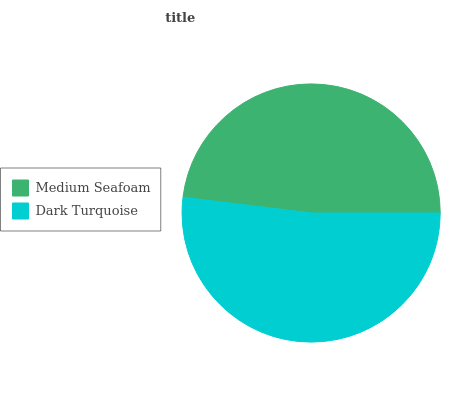Is Medium Seafoam the minimum?
Answer yes or no. Yes. Is Dark Turquoise the maximum?
Answer yes or no. Yes. Is Dark Turquoise the minimum?
Answer yes or no. No. Is Dark Turquoise greater than Medium Seafoam?
Answer yes or no. Yes. Is Medium Seafoam less than Dark Turquoise?
Answer yes or no. Yes. Is Medium Seafoam greater than Dark Turquoise?
Answer yes or no. No. Is Dark Turquoise less than Medium Seafoam?
Answer yes or no. No. Is Dark Turquoise the high median?
Answer yes or no. Yes. Is Medium Seafoam the low median?
Answer yes or no. Yes. Is Medium Seafoam the high median?
Answer yes or no. No. Is Dark Turquoise the low median?
Answer yes or no. No. 